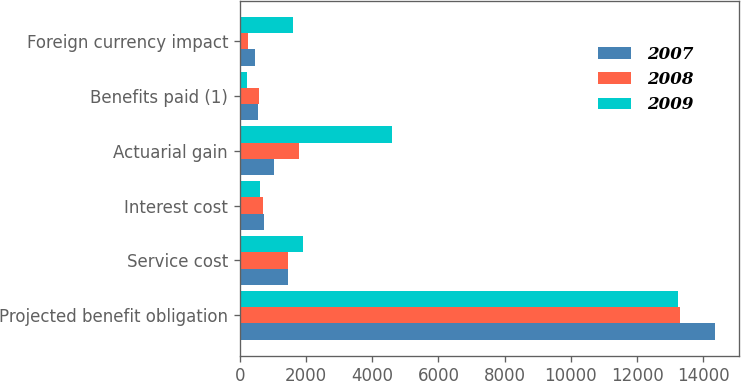Convert chart to OTSL. <chart><loc_0><loc_0><loc_500><loc_500><stacked_bar_chart><ecel><fcel>Projected benefit obligation<fcel>Service cost<fcel>Interest cost<fcel>Actuarial gain<fcel>Benefits paid (1)<fcel>Foreign currency impact<nl><fcel>2007<fcel>14358<fcel>1465<fcel>742<fcel>1034<fcel>562<fcel>461<nl><fcel>2008<fcel>13286<fcel>1470<fcel>717<fcel>1799<fcel>583<fcel>257<nl><fcel>2009<fcel>13224<fcel>1922<fcel>599<fcel>4589<fcel>217<fcel>1609<nl></chart> 